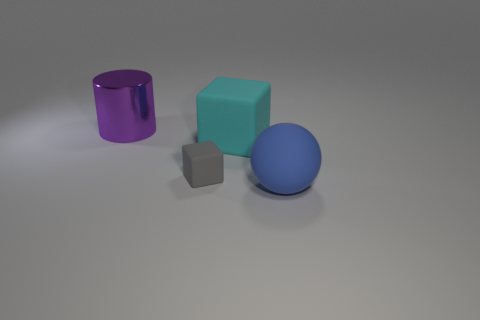Is the number of big cyan blocks greater than the number of cubes?
Provide a short and direct response. No. There is a matte thing that is in front of the big cyan block and left of the matte sphere; what size is it?
Offer a very short reply. Small. The big thing that is behind the big matte thing left of the thing in front of the gray matte block is made of what material?
Make the answer very short. Metal. There is a big matte thing that is to the left of the object to the right of the large rubber thing that is behind the blue sphere; what shape is it?
Provide a succinct answer. Cube. There is a object that is right of the gray rubber thing and behind the blue matte ball; what is its shape?
Your answer should be compact. Cube. How many things are behind the large rubber thing right of the large matte object that is behind the matte sphere?
Ensure brevity in your answer.  3. What size is the other rubber object that is the same shape as the big cyan rubber object?
Offer a terse response. Small. Is there any other thing that is the same size as the gray block?
Keep it short and to the point. No. Are the cube behind the tiny gray matte object and the gray thing made of the same material?
Your answer should be very brief. Yes. What color is the other small object that is the same shape as the cyan thing?
Your response must be concise. Gray. 